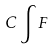Convert formula to latex. <formula><loc_0><loc_0><loc_500><loc_500>C \int F</formula> 